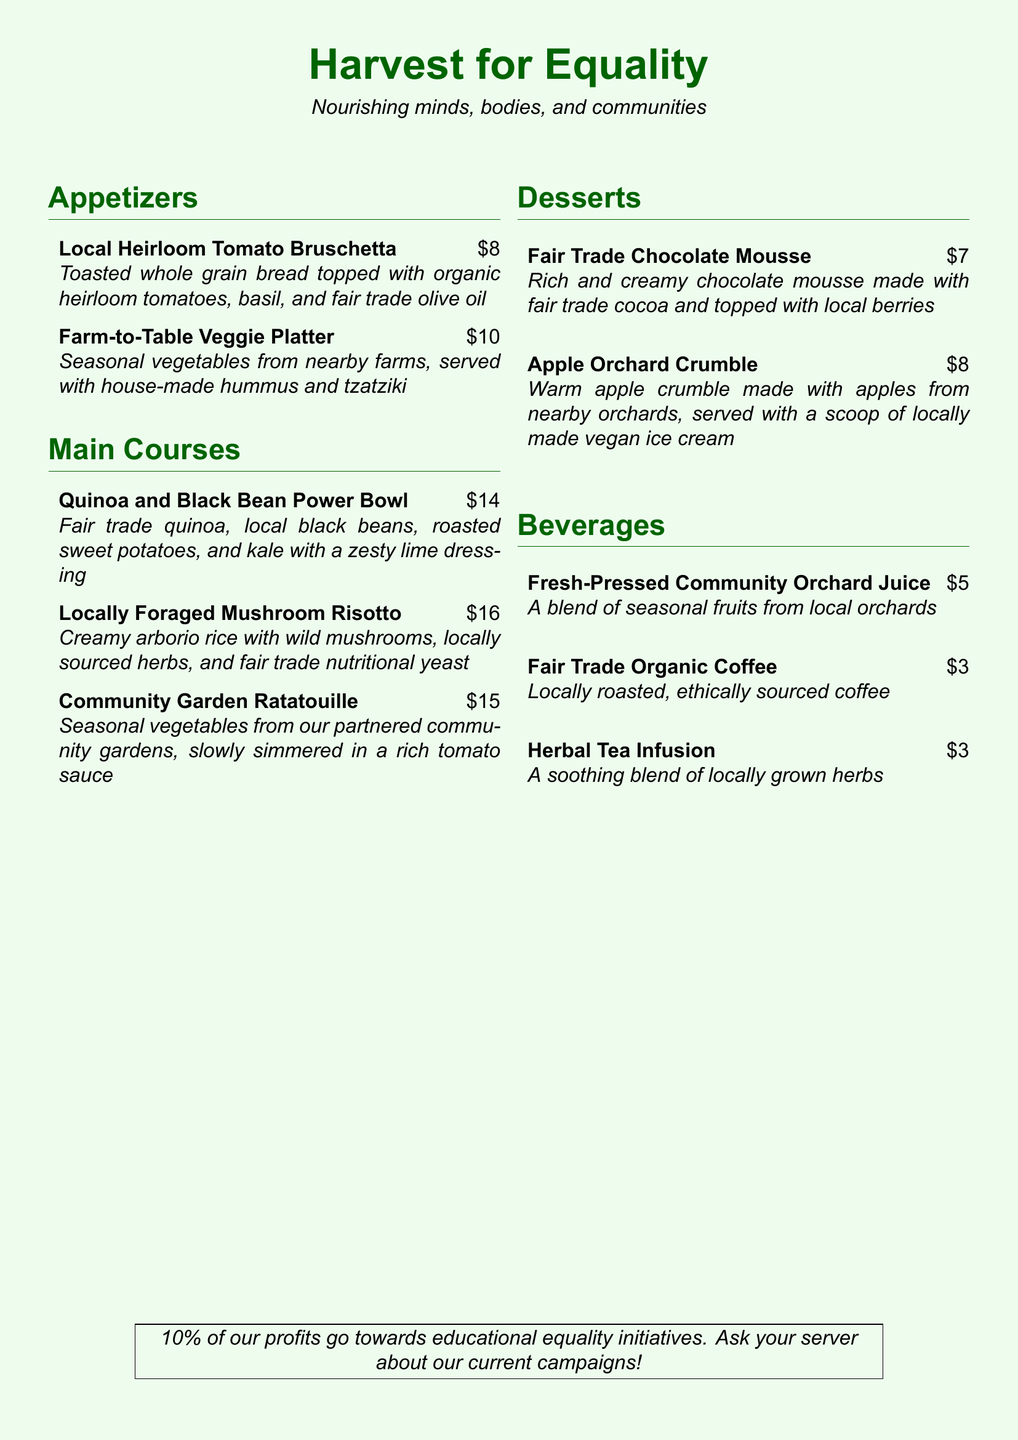What is the name of the restaurant? The name of the restaurant is prominently displayed at the top of the document as "Harvest for Equality."
Answer: Harvest for Equality What type of menu does the restaurant offer? The menu focuses on vegetarian options with an emphasis on locally-sourced ingredients and fair trade products.
Answer: Vegetarian-focused menu What is the price of the Quinoa and Black Bean Power Bowl? The price is listed next to the menu item. It is $14.
Answer: $14 How much of the profits is donated to educational equality initiatives? The document states that 10% of profits go towards educational equality initiatives.
Answer: 10% What dessert is made with fair trade cocoa? The Fair Trade Chocolate Mousse is the dessert made with fair trade cocoa.
Answer: Fair Trade Chocolate Mousse Which beverage is made from seasonal fruits? The Fresh-Pressed Community Orchard Juice is made from seasonal fruits.
Answer: Fresh-Pressed Community Orchard Juice How many appetizers are listed on the menu? There are two appetizers listed in the document under the Appetizers section.
Answer: Two Which dish includes locally foraged ingredients? The Locally Foraged Mushroom Risotto includes locally foraged ingredients.
Answer: Locally Foraged Mushroom Risotto 